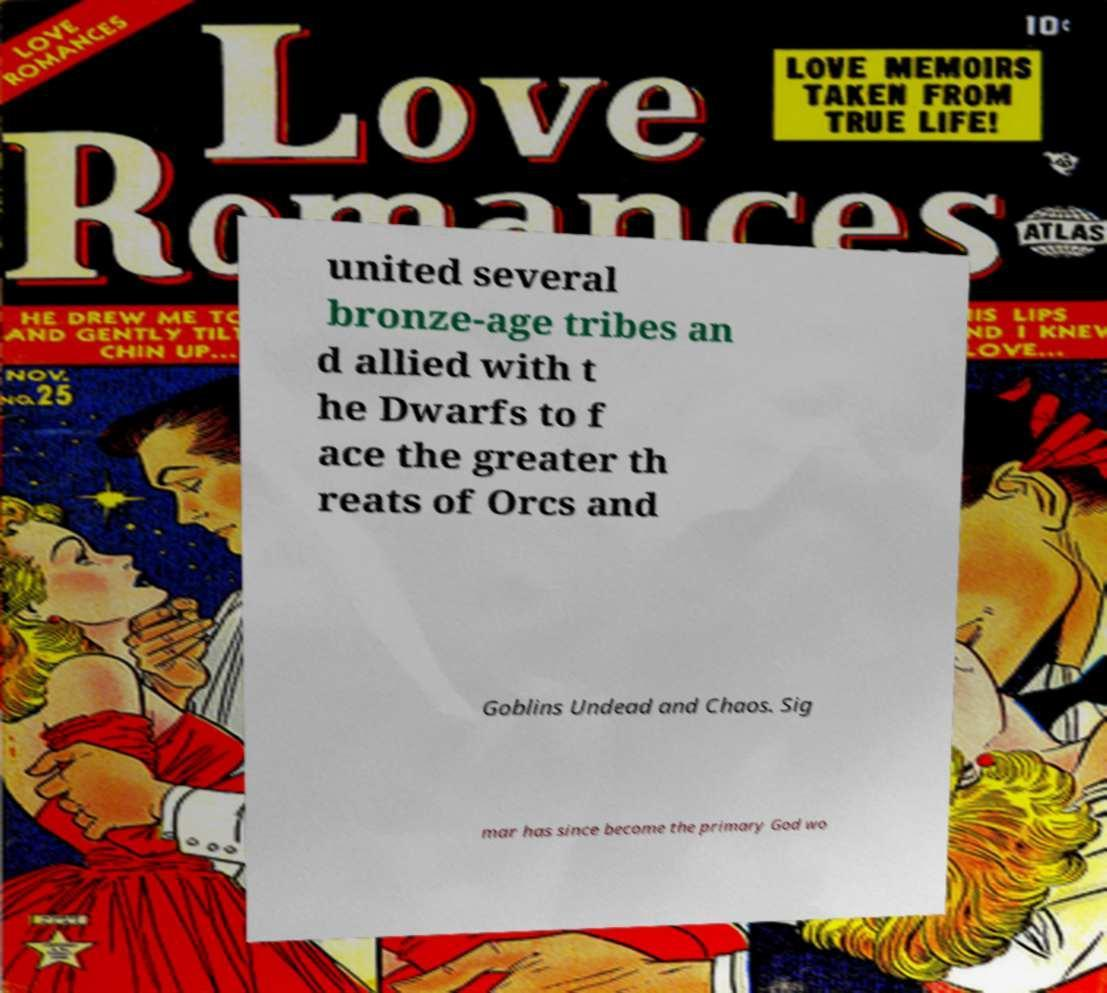Could you assist in decoding the text presented in this image and type it out clearly? united several bronze-age tribes an d allied with t he Dwarfs to f ace the greater th reats of Orcs and Goblins Undead and Chaos. Sig mar has since become the primary God wo 